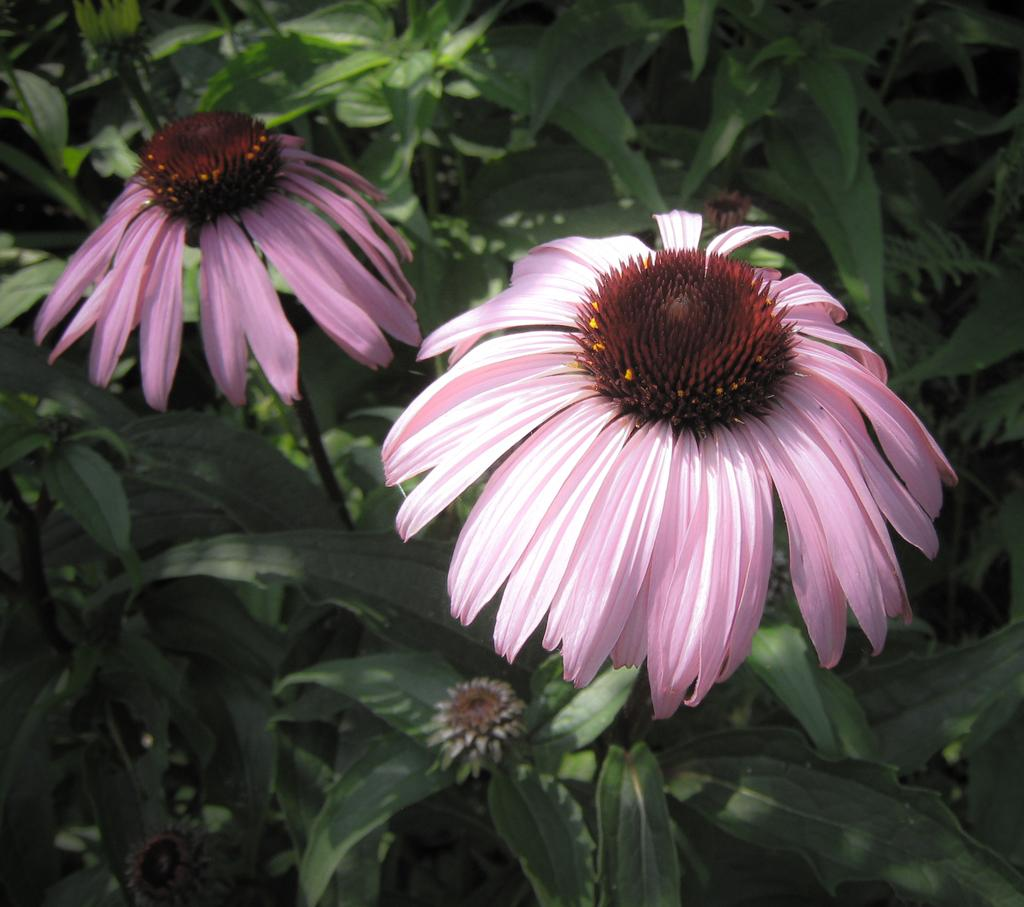How many flowers are present in the image? There are two flowers in the image. What color are the flowers? The flowers are pink in color. What can be seen in the background of the image? There are plants in the background of the image. What color are the plants? The plants are green in color. What route does the flower take to reach the top of the lift in the image? There is no lift present in the image, and the flowers are not moving. 